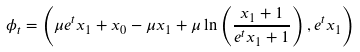<formula> <loc_0><loc_0><loc_500><loc_500>\phi _ { t } = \left ( \mu e ^ { t } x _ { 1 } + x _ { 0 } - \mu x _ { 1 } + \mu \ln \left ( \frac { x _ { 1 } + 1 } { e ^ { t } x _ { 1 } + 1 } \right ) , e ^ { t } x _ { 1 } \right )</formula> 